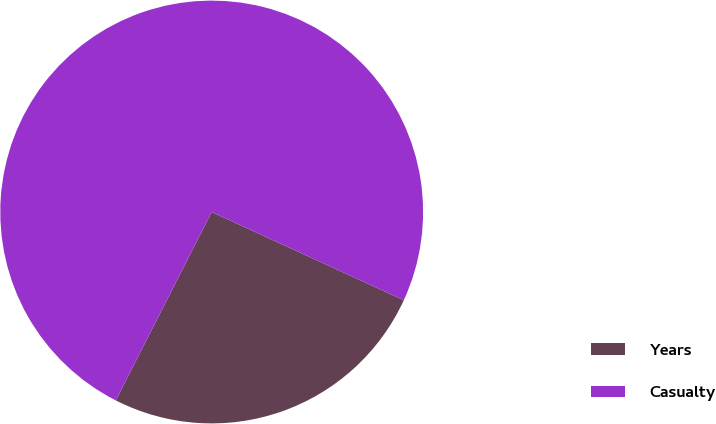Convert chart to OTSL. <chart><loc_0><loc_0><loc_500><loc_500><pie_chart><fcel>Years<fcel>Casualty<nl><fcel>25.64%<fcel>74.36%<nl></chart> 